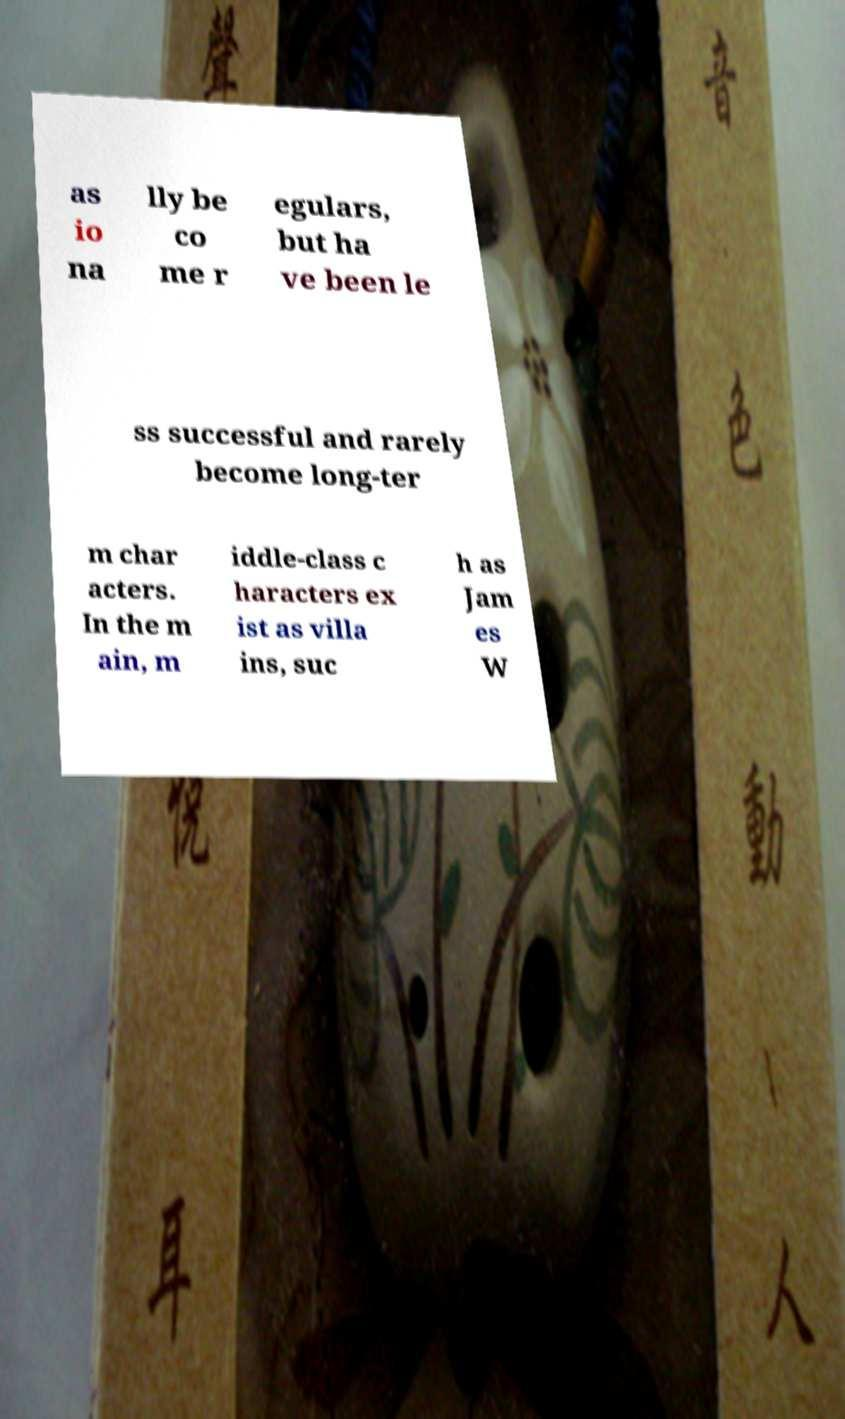I need the written content from this picture converted into text. Can you do that? as io na lly be co me r egulars, but ha ve been le ss successful and rarely become long-ter m char acters. In the m ain, m iddle-class c haracters ex ist as villa ins, suc h as Jam es W 